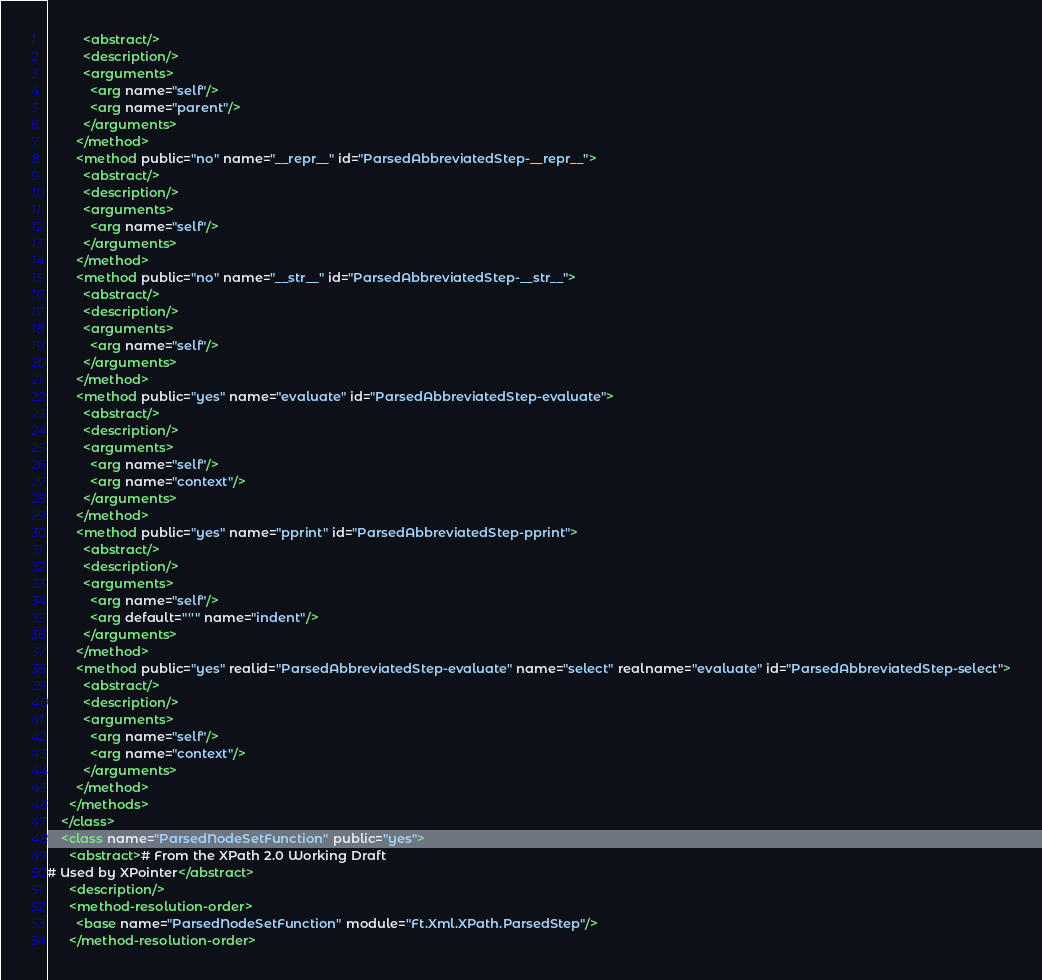Convert code to text. <code><loc_0><loc_0><loc_500><loc_500><_XML_>          <abstract/>
          <description/>
          <arguments>
            <arg name="self"/>
            <arg name="parent"/>
          </arguments>
        </method>
        <method public="no" name="__repr__" id="ParsedAbbreviatedStep-__repr__">
          <abstract/>
          <description/>
          <arguments>
            <arg name="self"/>
          </arguments>
        </method>
        <method public="no" name="__str__" id="ParsedAbbreviatedStep-__str__">
          <abstract/>
          <description/>
          <arguments>
            <arg name="self"/>
          </arguments>
        </method>
        <method public="yes" name="evaluate" id="ParsedAbbreviatedStep-evaluate">
          <abstract/>
          <description/>
          <arguments>
            <arg name="self"/>
            <arg name="context"/>
          </arguments>
        </method>
        <method public="yes" name="pprint" id="ParsedAbbreviatedStep-pprint">
          <abstract/>
          <description/>
          <arguments>
            <arg name="self"/>
            <arg default="''" name="indent"/>
          </arguments>
        </method>
        <method public="yes" realid="ParsedAbbreviatedStep-evaluate" name="select" realname="evaluate" id="ParsedAbbreviatedStep-select">
          <abstract/>
          <description/>
          <arguments>
            <arg name="self"/>
            <arg name="context"/>
          </arguments>
        </method>
      </methods>
    </class>
    <class name="ParsedNodeSetFunction" public="yes">
      <abstract># From the XPath 2.0 Working Draft
# Used by XPointer</abstract>
      <description/>
      <method-resolution-order>
        <base name="ParsedNodeSetFunction" module="Ft.Xml.XPath.ParsedStep"/>
      </method-resolution-order></code> 